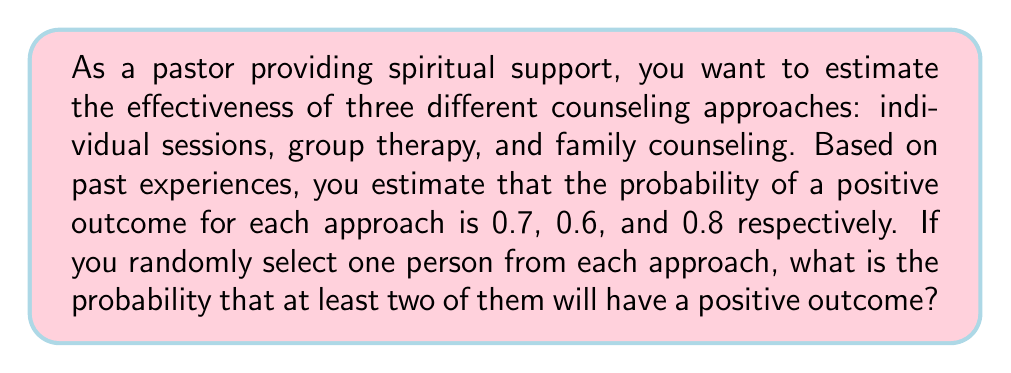Provide a solution to this math problem. Let's approach this step-by-step using probability theory:

1) First, let's define our events:
   A: Individual session has a positive outcome (P(A) = 0.7)
   B: Group therapy has a positive outcome (P(B) = 0.6)
   C: Family counseling has a positive outcome (P(C) = 0.8)

2) We want to find the probability of at least two positive outcomes. It's easier to calculate the complement of this event (0 or 1 positive outcomes) and subtract from 1.

3) Probability of 0 positive outcomes:
   $$P(\text{0 positive}) = (1-0.7)(1-0.6)(1-0.8) = 0.3 \times 0.4 \times 0.2 = 0.024$$

4) Probability of exactly 1 positive outcome:
   $$P(\text{1 positive}) = 0.7 \times 0.4 \times 0.2 + 0.3 \times 0.6 \times 0.2 + 0.3 \times 0.4 \times 0.8$$
   $$= 0.056 + 0.036 + 0.096 = 0.188$$

5) Probability of 0 or 1 positive outcomes:
   $$P(\text{0 or 1 positive}) = 0.024 + 0.188 = 0.212$$

6) Therefore, the probability of at least 2 positive outcomes is:
   $$P(\text{at least 2 positive}) = 1 - P(\text{0 or 1 positive}) = 1 - 0.212 = 0.788$$
Answer: 0.788 